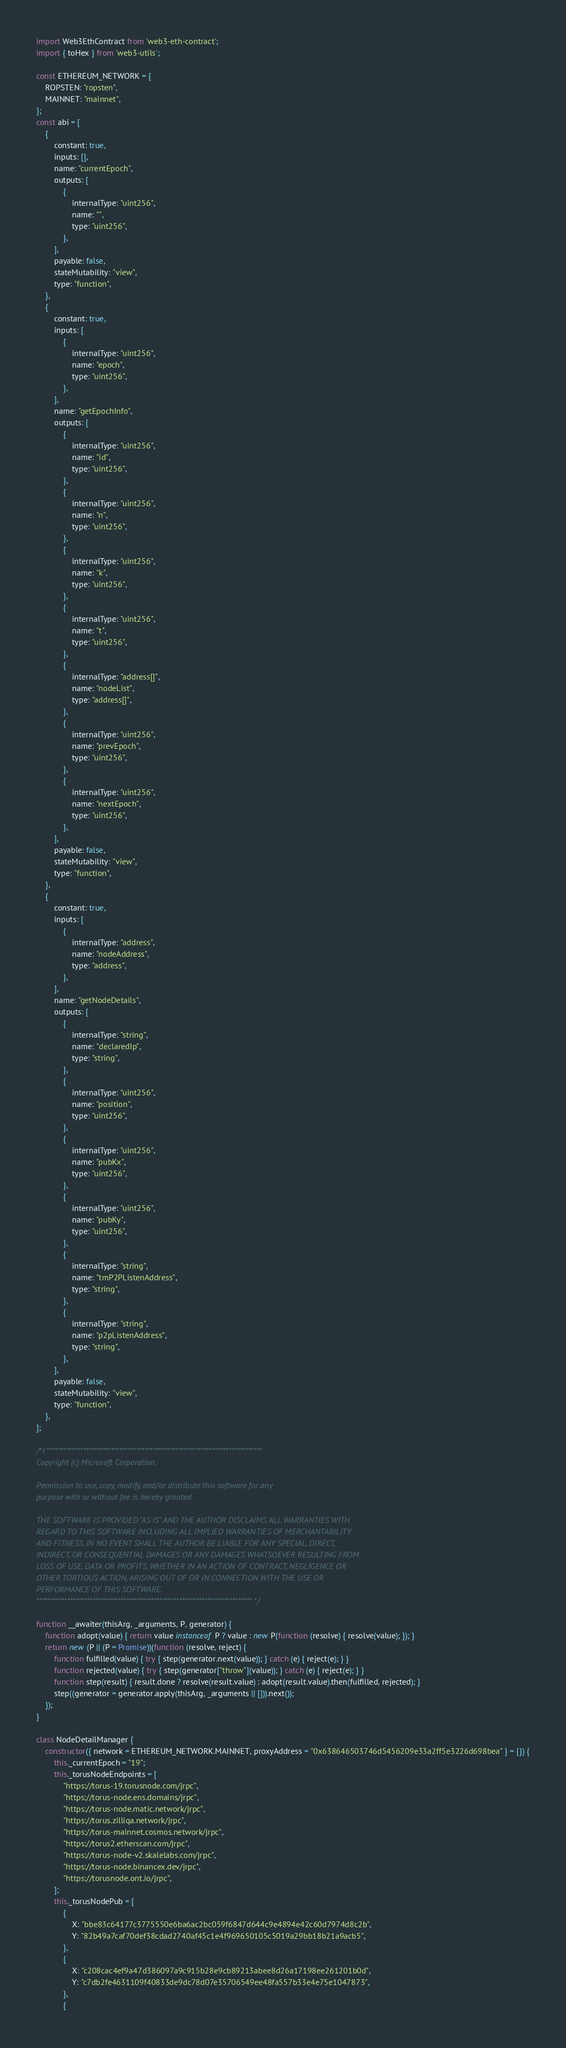Convert code to text. <code><loc_0><loc_0><loc_500><loc_500><_JavaScript_>import Web3EthContract from 'web3-eth-contract';
import { toHex } from 'web3-utils';

const ETHEREUM_NETWORK = {
    ROPSTEN: "ropsten",
    MAINNET: "mainnet",
};
const abi = [
    {
        constant: true,
        inputs: [],
        name: "currentEpoch",
        outputs: [
            {
                internalType: "uint256",
                name: "",
                type: "uint256",
            },
        ],
        payable: false,
        stateMutability: "view",
        type: "function",
    },
    {
        constant: true,
        inputs: [
            {
                internalType: "uint256",
                name: "epoch",
                type: "uint256",
            },
        ],
        name: "getEpochInfo",
        outputs: [
            {
                internalType: "uint256",
                name: "id",
                type: "uint256",
            },
            {
                internalType: "uint256",
                name: "n",
                type: "uint256",
            },
            {
                internalType: "uint256",
                name: "k",
                type: "uint256",
            },
            {
                internalType: "uint256",
                name: "t",
                type: "uint256",
            },
            {
                internalType: "address[]",
                name: "nodeList",
                type: "address[]",
            },
            {
                internalType: "uint256",
                name: "prevEpoch",
                type: "uint256",
            },
            {
                internalType: "uint256",
                name: "nextEpoch",
                type: "uint256",
            },
        ],
        payable: false,
        stateMutability: "view",
        type: "function",
    },
    {
        constant: true,
        inputs: [
            {
                internalType: "address",
                name: "nodeAddress",
                type: "address",
            },
        ],
        name: "getNodeDetails",
        outputs: [
            {
                internalType: "string",
                name: "declaredIp",
                type: "string",
            },
            {
                internalType: "uint256",
                name: "position",
                type: "uint256",
            },
            {
                internalType: "uint256",
                name: "pubKx",
                type: "uint256",
            },
            {
                internalType: "uint256",
                name: "pubKy",
                type: "uint256",
            },
            {
                internalType: "string",
                name: "tmP2PListenAddress",
                type: "string",
            },
            {
                internalType: "string",
                name: "p2pListenAddress",
                type: "string",
            },
        ],
        payable: false,
        stateMutability: "view",
        type: "function",
    },
];

/*! *****************************************************************************
Copyright (c) Microsoft Corporation.

Permission to use, copy, modify, and/or distribute this software for any
purpose with or without fee is hereby granted.

THE SOFTWARE IS PROVIDED "AS IS" AND THE AUTHOR DISCLAIMS ALL WARRANTIES WITH
REGARD TO THIS SOFTWARE INCLUDING ALL IMPLIED WARRANTIES OF MERCHANTABILITY
AND FITNESS. IN NO EVENT SHALL THE AUTHOR BE LIABLE FOR ANY SPECIAL, DIRECT,
INDIRECT, OR CONSEQUENTIAL DAMAGES OR ANY DAMAGES WHATSOEVER RESULTING FROM
LOSS OF USE, DATA OR PROFITS, WHETHER IN AN ACTION OF CONTRACT, NEGLIGENCE OR
OTHER TORTIOUS ACTION, ARISING OUT OF OR IN CONNECTION WITH THE USE OR
PERFORMANCE OF THIS SOFTWARE.
***************************************************************************** */

function __awaiter(thisArg, _arguments, P, generator) {
    function adopt(value) { return value instanceof P ? value : new P(function (resolve) { resolve(value); }); }
    return new (P || (P = Promise))(function (resolve, reject) {
        function fulfilled(value) { try { step(generator.next(value)); } catch (e) { reject(e); } }
        function rejected(value) { try { step(generator["throw"](value)); } catch (e) { reject(e); } }
        function step(result) { result.done ? resolve(result.value) : adopt(result.value).then(fulfilled, rejected); }
        step((generator = generator.apply(thisArg, _arguments || [])).next());
    });
}

class NodeDetailManager {
    constructor({ network = ETHEREUM_NETWORK.MAINNET, proxyAddress = "0x638646503746d5456209e33a2ff5e3226d698bea" } = {}) {
        this._currentEpoch = "19";
        this._torusNodeEndpoints = [
            "https://torus-19.torusnode.com/jrpc",
            "https://torus-node.ens.domains/jrpc",
            "https://torus-node.matic.network/jrpc",
            "https://torus.zilliqa.network/jrpc",
            "https://torus-mainnet.cosmos.network/jrpc",
            "https://torus2.etherscan.com/jrpc",
            "https://torus-node-v2.skalelabs.com/jrpc",
            "https://torus-node.binancex.dev/jrpc",
            "https://torusnode.ont.io/jrpc",
        ];
        this._torusNodePub = [
            {
                X: "bbe83c64177c3775550e6ba6ac2bc059f6847d644c9e4894e42c60d7974d8c2b",
                Y: "82b49a7caf70def38cdad2740af45c1e4f969650105c5019a29bb18b21a9acb5",
            },
            {
                X: "c208cac4ef9a47d386097a9c915b28e9cb89213abee8d26a17198ee261201b0d",
                Y: "c7db2fe4631109f40833de9dc78d07e35706549ee48fa557b33e4e75e1047873",
            },
            {</code> 